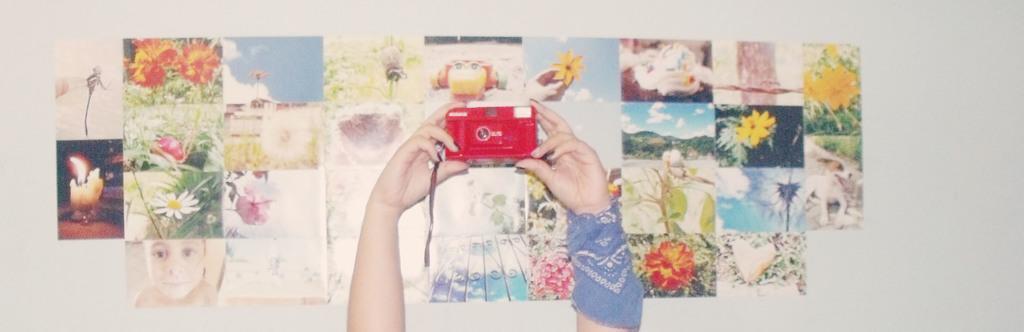How would you summarize this image in a sentence or two? In this image I can see a human hand holding a camera and the camera is in red color. Background I can see few papers attached to the wall and the wall is in white color. 